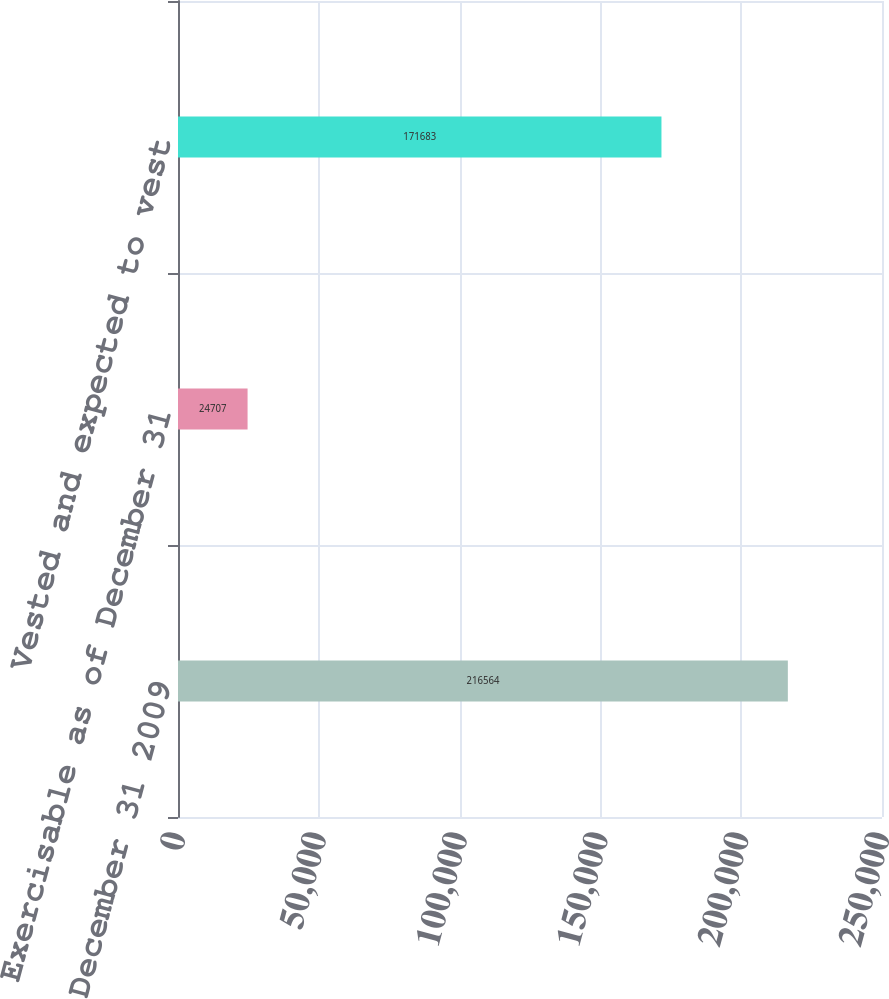Convert chart to OTSL. <chart><loc_0><loc_0><loc_500><loc_500><bar_chart><fcel>Balance as of December 31 2009<fcel>Exercisable as of December 31<fcel>Vested and expected to vest<nl><fcel>216564<fcel>24707<fcel>171683<nl></chart> 